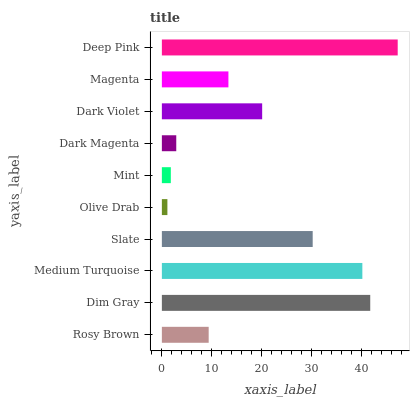Is Olive Drab the minimum?
Answer yes or no. Yes. Is Deep Pink the maximum?
Answer yes or no. Yes. Is Dim Gray the minimum?
Answer yes or no. No. Is Dim Gray the maximum?
Answer yes or no. No. Is Dim Gray greater than Rosy Brown?
Answer yes or no. Yes. Is Rosy Brown less than Dim Gray?
Answer yes or no. Yes. Is Rosy Brown greater than Dim Gray?
Answer yes or no. No. Is Dim Gray less than Rosy Brown?
Answer yes or no. No. Is Dark Violet the high median?
Answer yes or no. Yes. Is Magenta the low median?
Answer yes or no. Yes. Is Dark Magenta the high median?
Answer yes or no. No. Is Medium Turquoise the low median?
Answer yes or no. No. 